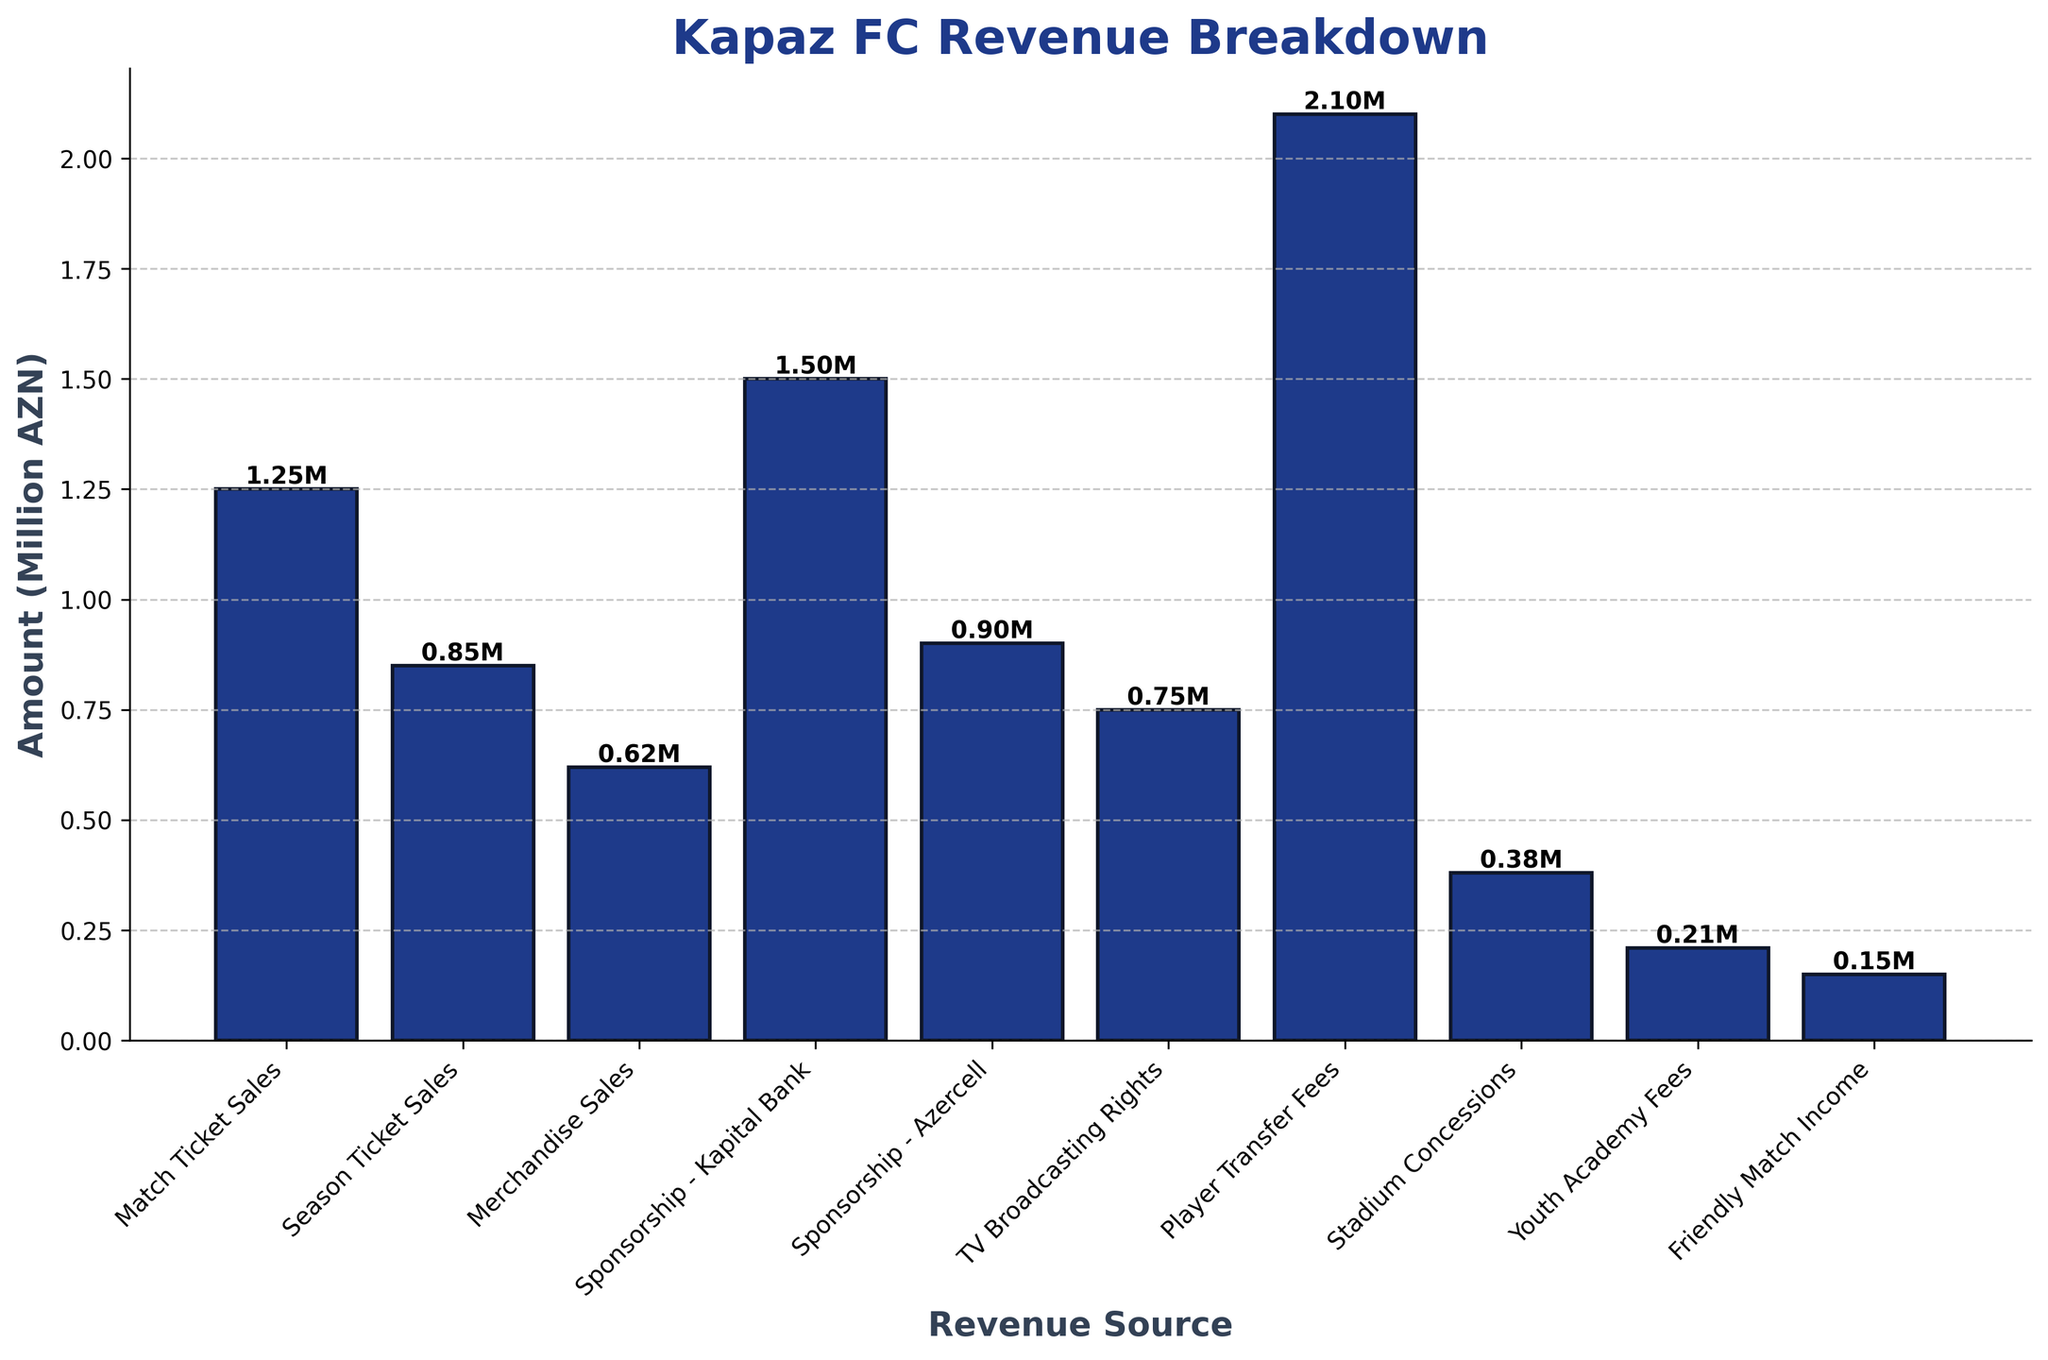Which revenue source generated the highest amount? The highest bar corresponds to Player Transfer Fees, which reaches the highest height on the y-axis.
Answer: Player Transfer Fees What is the total revenue from all sources combined? Sum the heights of all the bars: 1.25M + 0.85M + 0.62M + 1.50M + 0.90M + 0.75M + 2.10M + 0.38M + 0.21M + 0.15M. Total is 8.76M AZN.
Answer: 8.76M AZN How much more revenue did Player Transfer Fees generate compared to Match Ticket Sales? Subtract the height of the Match Ticket Sales bar (1.25M) from the Player Transfer Fees bar (2.10M): 2.10M - 1.25M = 0.85M.
Answer: 0.85M AZN Which sponsorship deals collectively generated more revenue, Kapital Bank and Azercell or TV Broadcasting Rights and Friendly Match Income? Add the heights of Kapital Bank and Azercell bars (1.50M + 0.90M = 2.40M) and compare them with the sum of TV Broadcasting Rights and Friendly Match Income (0.75M + 0.15M = 0.90M). 2.40M > 0.90M.
Answer: Kapital Bank and Azercell What is the average revenue generated by Season Ticket Sales and Merchandise Sales? Sum the heights of the bars for Season Ticket Sales and Merchandise Sales and divide by 2: (0.85M + 0.62M) / 2 = 0.74M AZN.
Answer: 0.74M AZN Is there any revenue source that contributed exactly half a million AZN? Refer to the labeled heights of the bars in the plot. None of the bars is exactly at 0.50M.
Answer: No Which income is closer to the stadium concessions, TV Broadcasting Rights or Friendly Match Income? Analyze the proximity of the bar heights to the Stadium Concessions bar (0.38M). TV Broadcasting Rights is at 0.75M and Friendly Match Income is at 0.15M. 0.38M is closer to 0.15M.
Answer: Friendly Match Income What percentage of the total revenue did Player Transfer Fees contribute? Calculate the percentage by dividing the height of Player Transfer Fees (2.10M) by the total revenue (8.76M) and multiplying by 100: (2.10M / 8.76M) * 100 ≈ 23.97%.
Answer: 23.97% Arrange the revenue sources in descending order of their amounts. Based on the bar heights from highest to lowest: Player Transfer Fees, Sponsorship - Kapital Bank, Match Ticket Sales, Sponsorship - Azercell, Season Ticket Sales, TV Broadcasting Rights, Merchandise Sales, Stadium Concessions, Youth Academy Fees, Friendly Match Income.
Answer: Player Transfer Fees; Sponsorship - Kapital Bank; Match Ticket Sales; Sponsorship - Azercell; Season Ticket Sales; TV Broadcasting Rights; Merchandise Sales; Stadium Concessions; Youth Academy Fees; Friendly Match Income Which revenue sources are less than 1 million AZN? Identify the bars with heights less than 1.00M: Merchandise Sales (0.62M), Stadium Concessions (0.38M), Youth Academy Fees (0.21M), Friendly Match Income (0.15M).
Answer: Merchandise Sales; Stadium Concessions; Youth Academy Fees; Friendly Match Income 